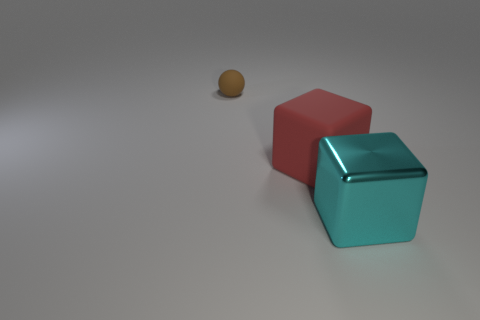What number of big blocks are in front of the red block and behind the cyan metal thing?
Ensure brevity in your answer.  0. Are there any other things that are the same shape as the shiny thing?
Give a very brief answer. Yes. What size is the cube behind the cyan thing?
Offer a terse response. Large. What is the material of the thing behind the rubber object that is in front of the small brown rubber object?
Offer a very short reply. Rubber. Is there anything else that is the same material as the red object?
Provide a short and direct response. Yes. How many other red things have the same shape as the big metal object?
Provide a succinct answer. 1. What is the size of the thing that is the same material as the tiny brown ball?
Give a very brief answer. Large. There is a matte thing that is in front of the object that is on the left side of the big red rubber object; are there any matte spheres to the right of it?
Keep it short and to the point. No. There is a rubber object to the right of the brown thing; is it the same size as the brown matte ball?
Offer a very short reply. No. What number of yellow rubber balls have the same size as the matte cube?
Provide a short and direct response. 0. 